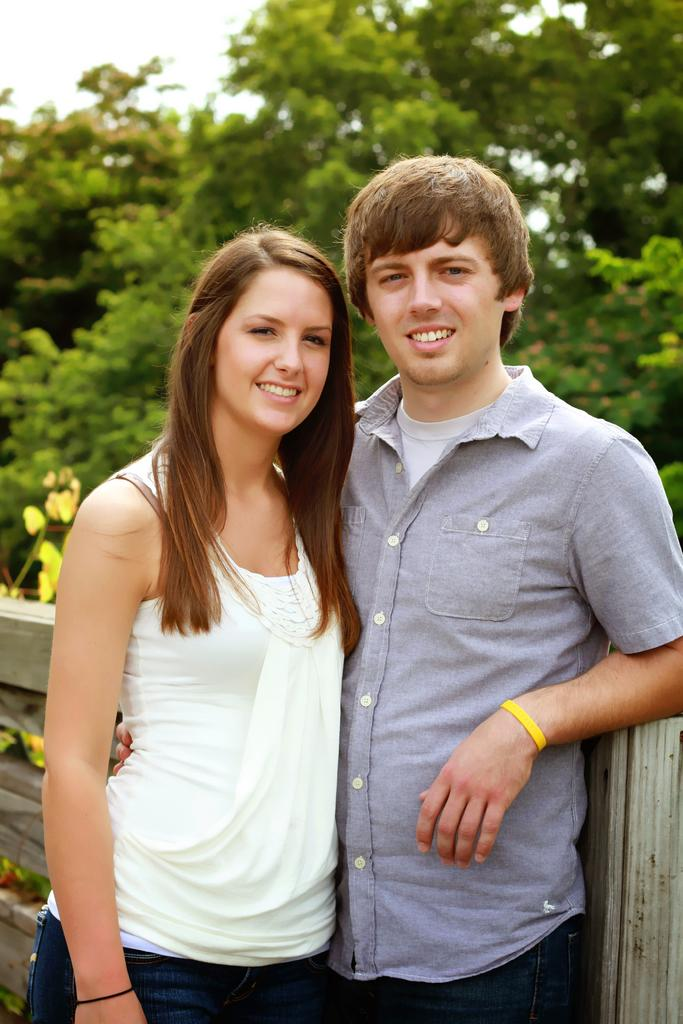How many people are present in the image? There are two persons standing in the image. What can be seen in the background of the image? There is fencing and trees in the background of the image. What is the color of the trees in the image? The trees are green in color. What is visible in the sky in the image? The sky is visible in the image, and it is white in color. What type of plant is used to make the jam in the image? There is no jam present in the image, so it is not possible to determine what type of plant might be used to make it. 